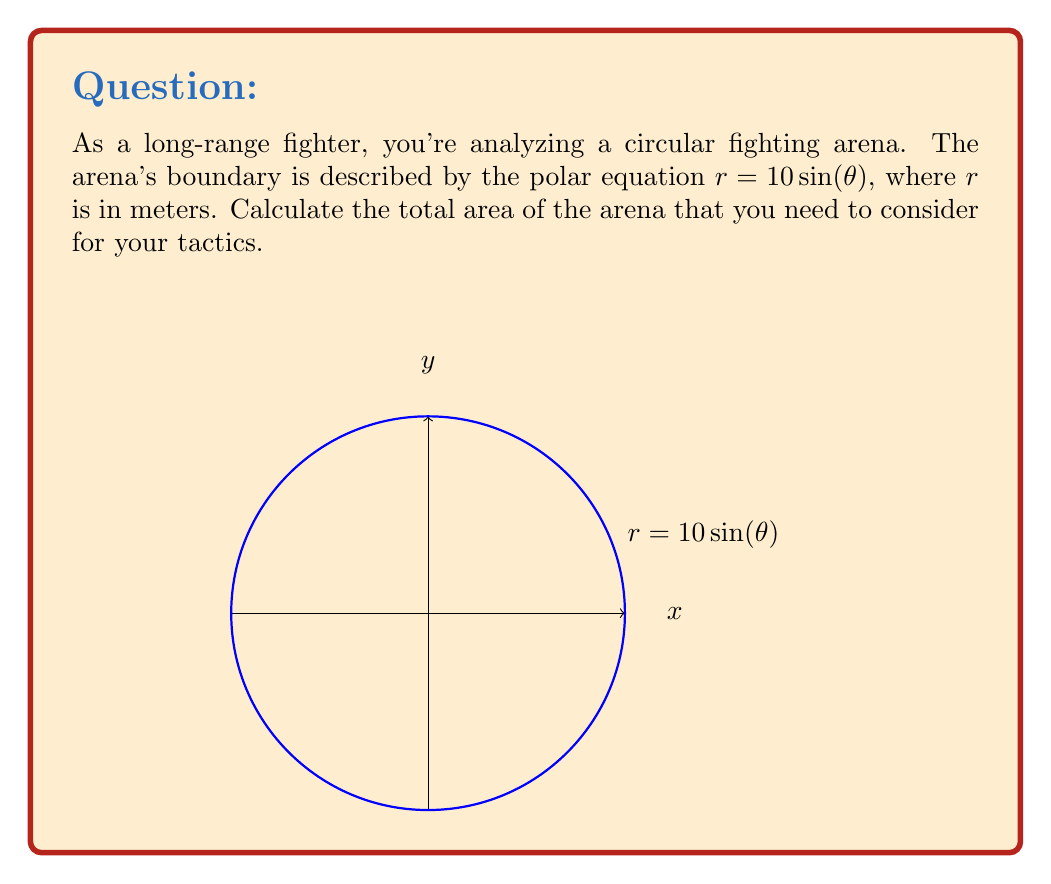Solve this math problem. Let's approach this step-by-step:

1) The area of a region in polar coordinates is given by the formula:

   $$A = \frac{1}{2} \int_a^b r^2(\theta) d\theta$$

2) In this case, $r(\theta) = 10 \sin(\theta)$, and we need to integrate over the full circle, so $a = 0$ and $b = 2\pi$.

3) Substituting into the formula:

   $$A = \frac{1}{2} \int_0^{2\pi} (10 \sin(\theta))^2 d\theta$$

4) Simplify the integrand:

   $$A = 50 \int_0^{2\pi} \sin^2(\theta) d\theta$$

5) Use the trigonometric identity $\sin^2(\theta) = \frac{1 - \cos(2\theta)}{2}$:

   $$A = 50 \int_0^{2\pi} \frac{1 - \cos(2\theta)}{2} d\theta$$

6) Simplify:

   $$A = 25 \int_0^{2\pi} (1 - \cos(2\theta)) d\theta$$

7) Integrate:

   $$A = 25 [\theta - \frac{1}{2}\sin(2\theta)]_0^{2\pi}$$

8) Evaluate the limits:

   $$A = 25 [(2\pi - 0) - (\frac{1}{2}\sin(4\pi) - \frac{1}{2}\sin(0))]$$

9) Simplify:

   $$A = 25 \cdot 2\pi = 50\pi$$

Therefore, the area of the arena is $50\pi$ square meters.
Answer: $50\pi$ m² 